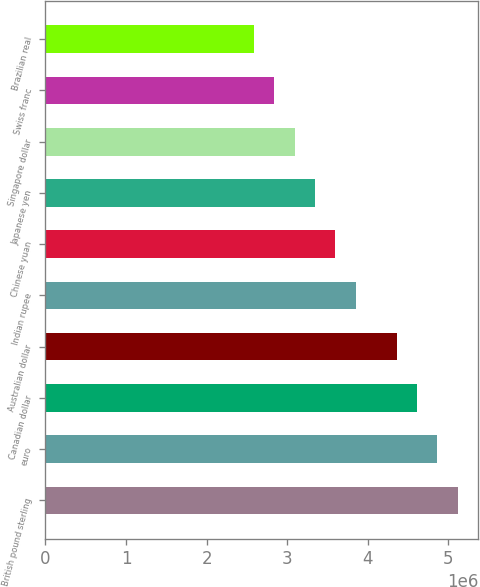Convert chart. <chart><loc_0><loc_0><loc_500><loc_500><bar_chart><fcel>British pound sterling<fcel>euro<fcel>Canadian dollar<fcel>Australian dollar<fcel>Indian rupee<fcel>Chinese yuan<fcel>Japanese yen<fcel>Singapore dollar<fcel>Swiss franc<fcel>Brazilian real<nl><fcel>5.11879e+06<fcel>4.8656e+06<fcel>4.61241e+06<fcel>4.35922e+06<fcel>3.85284e+06<fcel>3.59965e+06<fcel>3.34646e+06<fcel>3.09327e+06<fcel>2.84008e+06<fcel>2.58689e+06<nl></chart> 